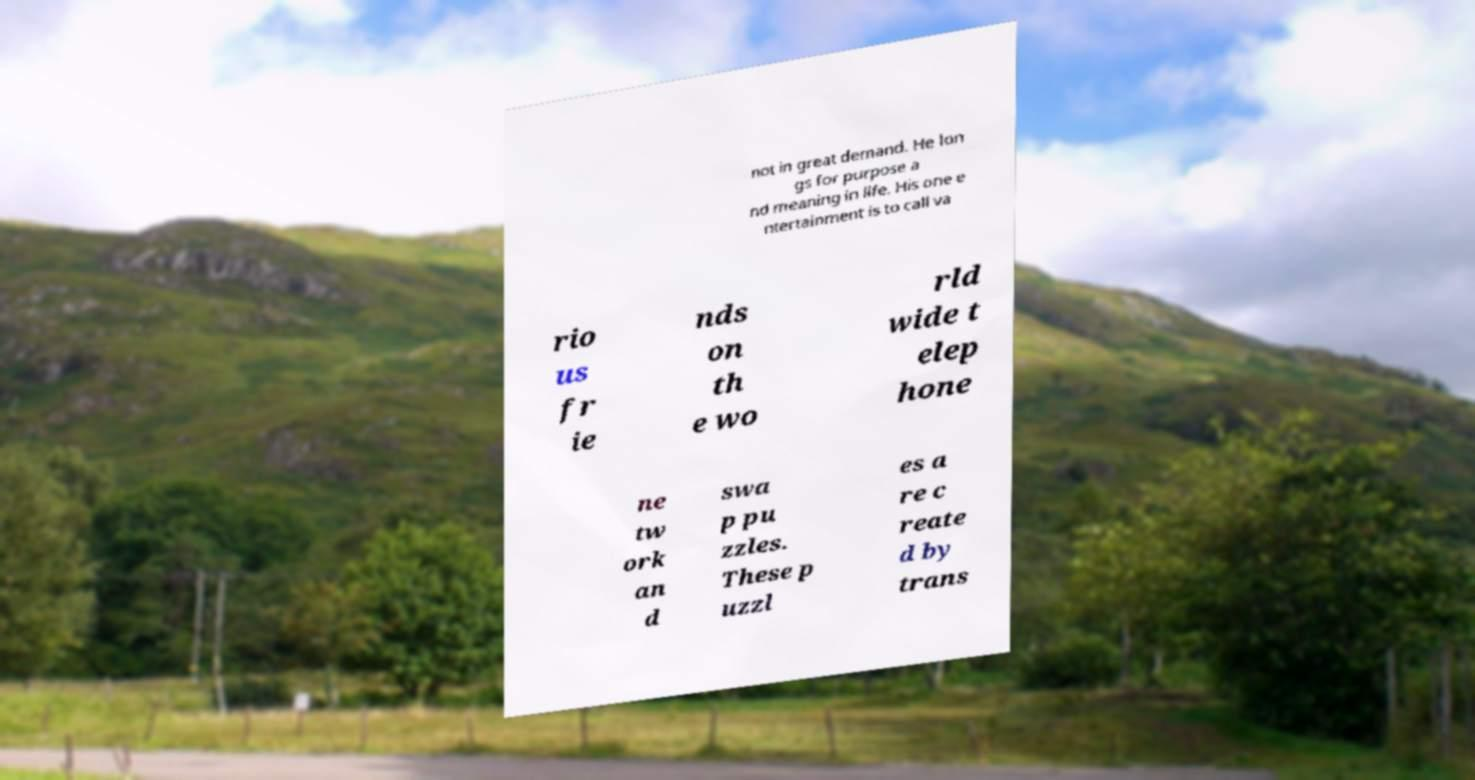There's text embedded in this image that I need extracted. Can you transcribe it verbatim? not in great demand. He lon gs for purpose a nd meaning in life. His one e ntertainment is to call va rio us fr ie nds on th e wo rld wide t elep hone ne tw ork an d swa p pu zzles. These p uzzl es a re c reate d by trans 